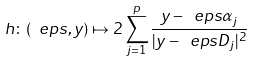<formula> <loc_0><loc_0><loc_500><loc_500>h \colon ( \ e p s , y ) \mapsto 2 \sum _ { j = 1 } ^ { p } \frac { y - \ e p s \alpha _ { j } } { | y - \ e p s D _ { j } | ^ { 2 } }</formula> 